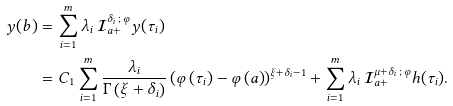<formula> <loc_0><loc_0><loc_500><loc_500>y ( b ) & = \sum _ { i = 1 } ^ { m } \lambda _ { i } \, \mathcal { I } _ { a + } ^ { \delta _ { i } \, ; \, \varphi } y ( \tau _ { i } ) \\ & = C _ { 1 } \sum _ { i = 1 } ^ { m } \frac { \lambda _ { i } } { \Gamma \left ( \xi + \delta _ { i } \right ) } \left ( \varphi \left ( \tau _ { i } \right ) - \varphi \left ( a \right ) \right ) ^ { \xi + \delta _ { i } - 1 } + \sum _ { i = 1 } ^ { m } \lambda _ { i } \, \mathcal { I } _ { a + } ^ { \mu + \delta _ { i } \, ; \, \varphi } h ( \tau _ { i } ) .</formula> 